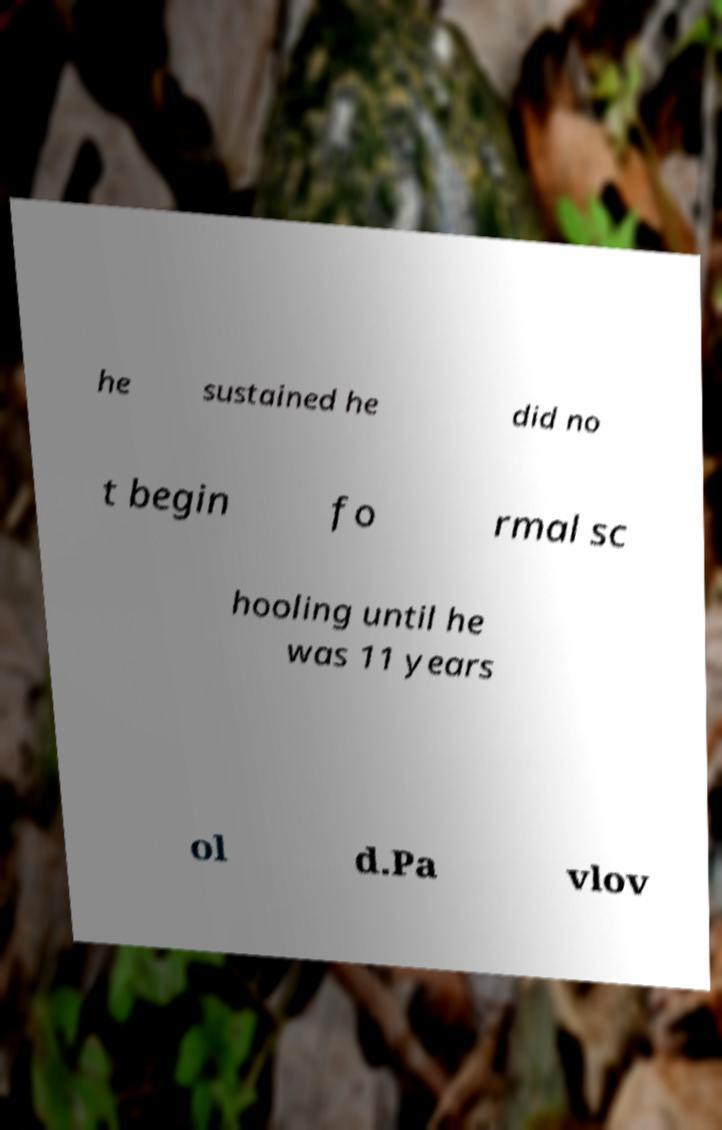I need the written content from this picture converted into text. Can you do that? he sustained he did no t begin fo rmal sc hooling until he was 11 years ol d.Pa vlov 